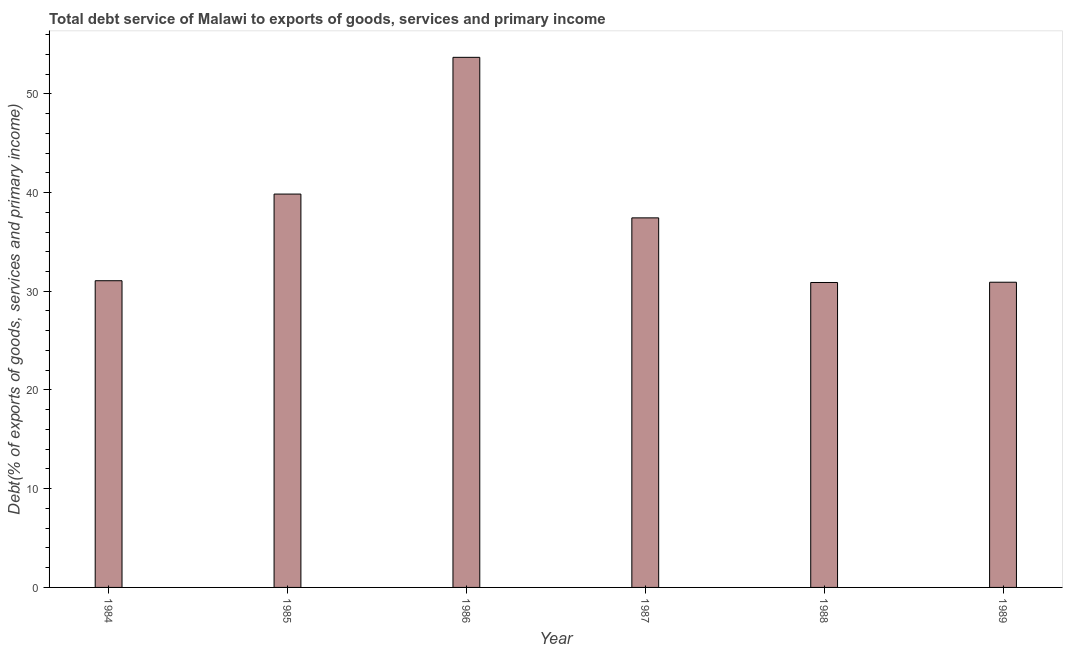What is the title of the graph?
Give a very brief answer. Total debt service of Malawi to exports of goods, services and primary income. What is the label or title of the Y-axis?
Ensure brevity in your answer.  Debt(% of exports of goods, services and primary income). What is the total debt service in 1986?
Make the answer very short. 53.69. Across all years, what is the maximum total debt service?
Keep it short and to the point. 53.69. Across all years, what is the minimum total debt service?
Give a very brief answer. 30.89. What is the sum of the total debt service?
Provide a short and direct response. 223.83. What is the difference between the total debt service in 1984 and 1985?
Provide a short and direct response. -8.78. What is the average total debt service per year?
Make the answer very short. 37.3. What is the median total debt service?
Make the answer very short. 34.25. In how many years, is the total debt service greater than 40 %?
Provide a succinct answer. 1. What is the ratio of the total debt service in 1984 to that in 1985?
Keep it short and to the point. 0.78. Is the difference between the total debt service in 1984 and 1987 greater than the difference between any two years?
Ensure brevity in your answer.  No. What is the difference between the highest and the second highest total debt service?
Keep it short and to the point. 13.85. Is the sum of the total debt service in 1984 and 1989 greater than the maximum total debt service across all years?
Your answer should be compact. Yes. What is the difference between the highest and the lowest total debt service?
Make the answer very short. 22.81. How many years are there in the graph?
Offer a terse response. 6. What is the difference between two consecutive major ticks on the Y-axis?
Offer a terse response. 10. What is the Debt(% of exports of goods, services and primary income) of 1984?
Ensure brevity in your answer.  31.07. What is the Debt(% of exports of goods, services and primary income) of 1985?
Offer a terse response. 39.84. What is the Debt(% of exports of goods, services and primary income) of 1986?
Offer a terse response. 53.69. What is the Debt(% of exports of goods, services and primary income) of 1987?
Give a very brief answer. 37.43. What is the Debt(% of exports of goods, services and primary income) of 1988?
Provide a succinct answer. 30.89. What is the Debt(% of exports of goods, services and primary income) of 1989?
Your answer should be very brief. 30.91. What is the difference between the Debt(% of exports of goods, services and primary income) in 1984 and 1985?
Make the answer very short. -8.78. What is the difference between the Debt(% of exports of goods, services and primary income) in 1984 and 1986?
Give a very brief answer. -22.63. What is the difference between the Debt(% of exports of goods, services and primary income) in 1984 and 1987?
Your response must be concise. -6.37. What is the difference between the Debt(% of exports of goods, services and primary income) in 1984 and 1988?
Offer a terse response. 0.18. What is the difference between the Debt(% of exports of goods, services and primary income) in 1984 and 1989?
Ensure brevity in your answer.  0.15. What is the difference between the Debt(% of exports of goods, services and primary income) in 1985 and 1986?
Provide a succinct answer. -13.85. What is the difference between the Debt(% of exports of goods, services and primary income) in 1985 and 1987?
Ensure brevity in your answer.  2.41. What is the difference between the Debt(% of exports of goods, services and primary income) in 1985 and 1988?
Your response must be concise. 8.96. What is the difference between the Debt(% of exports of goods, services and primary income) in 1985 and 1989?
Your answer should be very brief. 8.93. What is the difference between the Debt(% of exports of goods, services and primary income) in 1986 and 1987?
Ensure brevity in your answer.  16.26. What is the difference between the Debt(% of exports of goods, services and primary income) in 1986 and 1988?
Give a very brief answer. 22.81. What is the difference between the Debt(% of exports of goods, services and primary income) in 1986 and 1989?
Your response must be concise. 22.78. What is the difference between the Debt(% of exports of goods, services and primary income) in 1987 and 1988?
Offer a very short reply. 6.55. What is the difference between the Debt(% of exports of goods, services and primary income) in 1987 and 1989?
Your answer should be compact. 6.52. What is the difference between the Debt(% of exports of goods, services and primary income) in 1988 and 1989?
Your answer should be compact. -0.03. What is the ratio of the Debt(% of exports of goods, services and primary income) in 1984 to that in 1985?
Make the answer very short. 0.78. What is the ratio of the Debt(% of exports of goods, services and primary income) in 1984 to that in 1986?
Offer a very short reply. 0.58. What is the ratio of the Debt(% of exports of goods, services and primary income) in 1984 to that in 1987?
Give a very brief answer. 0.83. What is the ratio of the Debt(% of exports of goods, services and primary income) in 1984 to that in 1988?
Keep it short and to the point. 1.01. What is the ratio of the Debt(% of exports of goods, services and primary income) in 1984 to that in 1989?
Offer a very short reply. 1. What is the ratio of the Debt(% of exports of goods, services and primary income) in 1985 to that in 1986?
Your answer should be very brief. 0.74. What is the ratio of the Debt(% of exports of goods, services and primary income) in 1985 to that in 1987?
Your response must be concise. 1.06. What is the ratio of the Debt(% of exports of goods, services and primary income) in 1985 to that in 1988?
Ensure brevity in your answer.  1.29. What is the ratio of the Debt(% of exports of goods, services and primary income) in 1985 to that in 1989?
Provide a succinct answer. 1.29. What is the ratio of the Debt(% of exports of goods, services and primary income) in 1986 to that in 1987?
Your answer should be compact. 1.43. What is the ratio of the Debt(% of exports of goods, services and primary income) in 1986 to that in 1988?
Your response must be concise. 1.74. What is the ratio of the Debt(% of exports of goods, services and primary income) in 1986 to that in 1989?
Provide a succinct answer. 1.74. What is the ratio of the Debt(% of exports of goods, services and primary income) in 1987 to that in 1988?
Give a very brief answer. 1.21. What is the ratio of the Debt(% of exports of goods, services and primary income) in 1987 to that in 1989?
Your response must be concise. 1.21. What is the ratio of the Debt(% of exports of goods, services and primary income) in 1988 to that in 1989?
Ensure brevity in your answer.  1. 